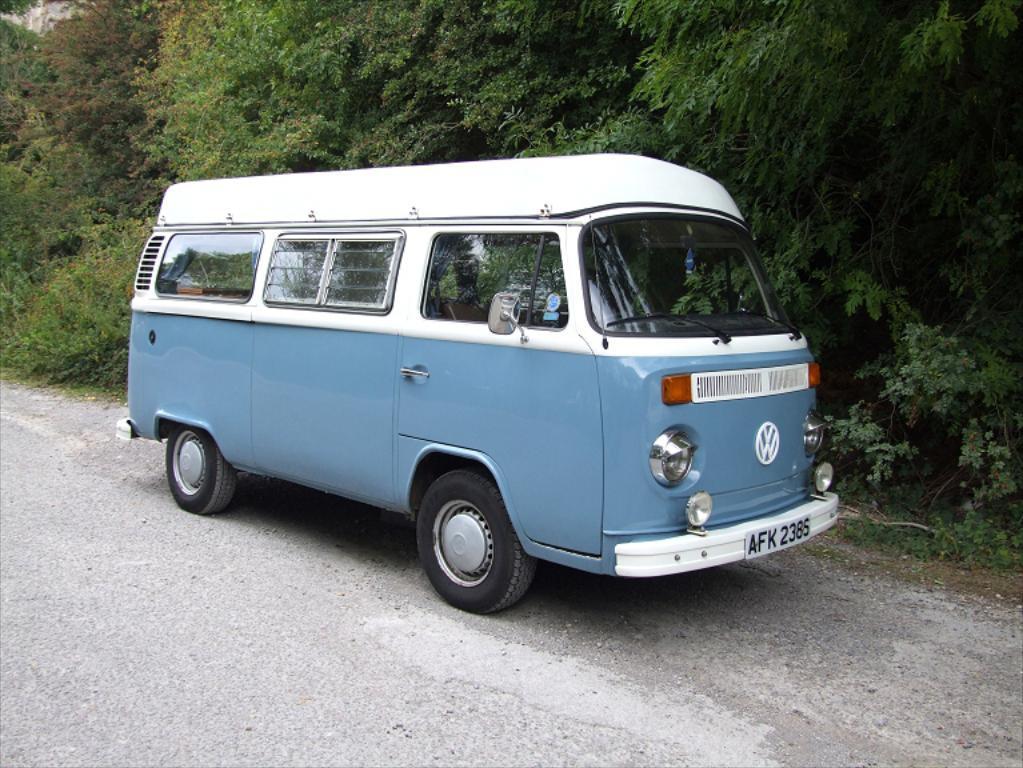How would you summarize this image in a sentence or two? In this image in the front there is a vehicle on the road which is white and grey in colour. In the background there are trees. 